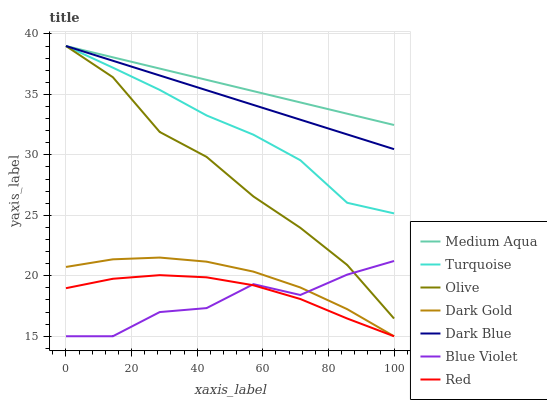Does Blue Violet have the minimum area under the curve?
Answer yes or no. Yes. Does Medium Aqua have the maximum area under the curve?
Answer yes or no. Yes. Does Dark Gold have the minimum area under the curve?
Answer yes or no. No. Does Dark Gold have the maximum area under the curve?
Answer yes or no. No. Is Medium Aqua the smoothest?
Answer yes or no. Yes. Is Blue Violet the roughest?
Answer yes or no. Yes. Is Dark Gold the smoothest?
Answer yes or no. No. Is Dark Gold the roughest?
Answer yes or no. No. Does Dark Gold have the lowest value?
Answer yes or no. Yes. Does Dark Blue have the lowest value?
Answer yes or no. No. Does Olive have the highest value?
Answer yes or no. Yes. Does Dark Gold have the highest value?
Answer yes or no. No. Is Red less than Turquoise?
Answer yes or no. Yes. Is Medium Aqua greater than Red?
Answer yes or no. Yes. Does Medium Aqua intersect Turquoise?
Answer yes or no. Yes. Is Medium Aqua less than Turquoise?
Answer yes or no. No. Is Medium Aqua greater than Turquoise?
Answer yes or no. No. Does Red intersect Turquoise?
Answer yes or no. No. 